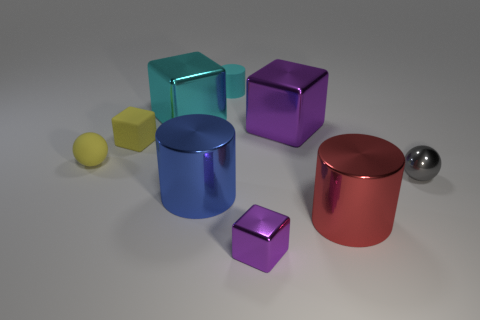What number of big green things are there?
Your answer should be very brief. 0. What is the color of the ball that is made of the same material as the tiny purple cube?
Your answer should be compact. Gray. Is the number of big things greater than the number of small yellow cubes?
Give a very brief answer. Yes. What is the size of the metallic thing that is behind the large blue metal thing and in front of the rubber cube?
Offer a terse response. Small. What material is the ball that is the same color as the small rubber block?
Your answer should be very brief. Rubber. Are there an equal number of tiny yellow rubber blocks that are in front of the matte ball and tiny yellow objects?
Provide a short and direct response. No. Do the gray shiny object and the cyan cylinder have the same size?
Ensure brevity in your answer.  Yes. What color is the cylinder that is both behind the large red metal object and in front of the large cyan thing?
Your answer should be compact. Blue. What is the tiny cube behind the block in front of the tiny yellow sphere made of?
Your response must be concise. Rubber. There is a blue thing that is the same shape as the large red thing; what size is it?
Provide a short and direct response. Large. 